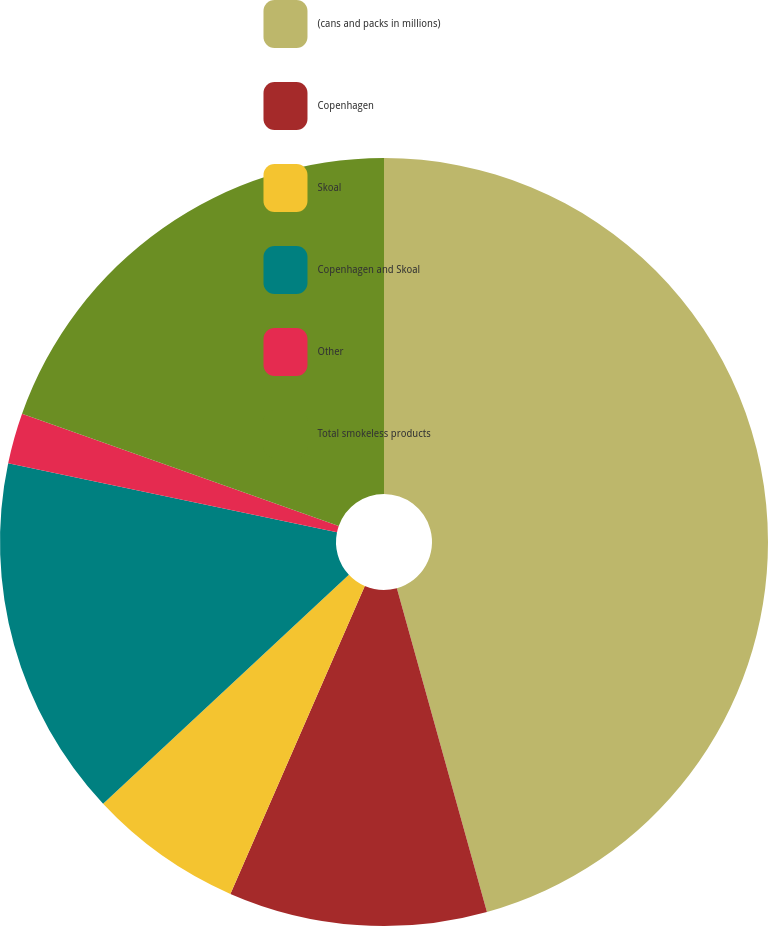Convert chart. <chart><loc_0><loc_0><loc_500><loc_500><pie_chart><fcel>(cans and packs in millions)<fcel>Copenhagen<fcel>Skoal<fcel>Copenhagen and Skoal<fcel>Other<fcel>Total smokeless products<nl><fcel>45.68%<fcel>10.87%<fcel>6.51%<fcel>15.23%<fcel>2.13%<fcel>19.58%<nl></chart> 